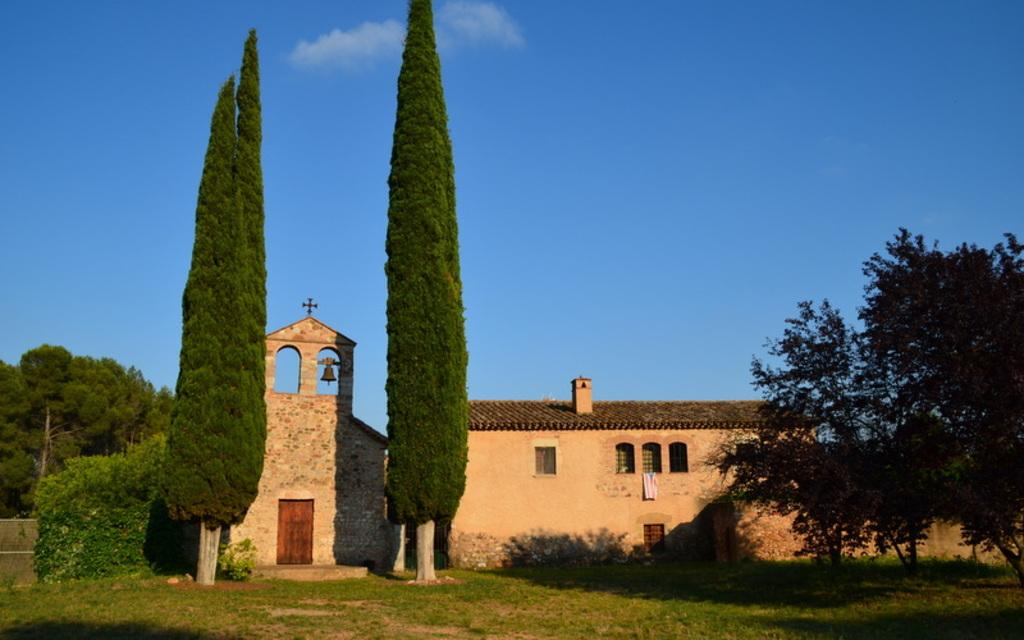What is located in the center of the image? There are buildings in the center of the image. What type of vegetation can be seen in the image? There are trees visible in the image. What is visible in the background of the image? The sky is visible in the background of the image. What type of bushes can be seen in the image? There are no bushes present in the image; it features buildings, trees, and the sky. What is the topic of the discussion taking place in the image? There is no discussion taking place in the image, as it is a still image of buildings, trees, and the sky. 